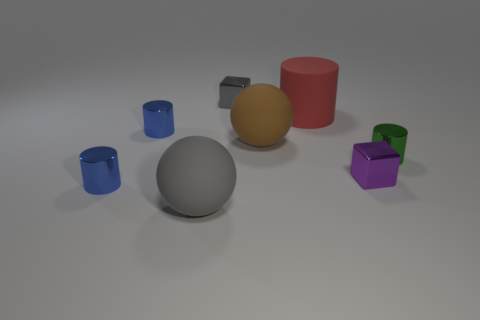Add 2 big red rubber cylinders. How many objects exist? 10 Subtract all spheres. How many objects are left? 6 Subtract all brown rubber balls. Subtract all big rubber spheres. How many objects are left? 5 Add 6 tiny purple things. How many tiny purple things are left? 7 Add 5 tiny green cylinders. How many tiny green cylinders exist? 6 Subtract 0 blue cubes. How many objects are left? 8 